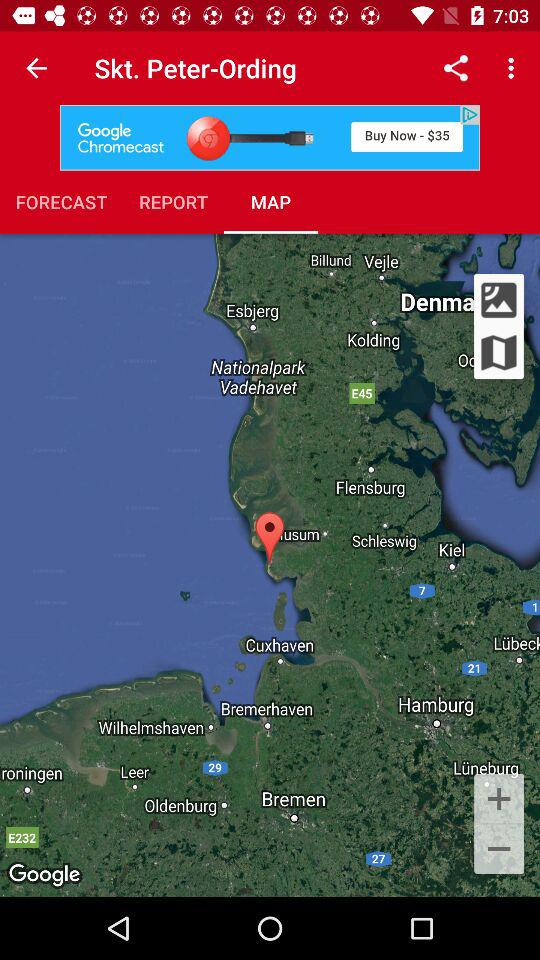Which tab is selected? The selected tab is "MAP". 